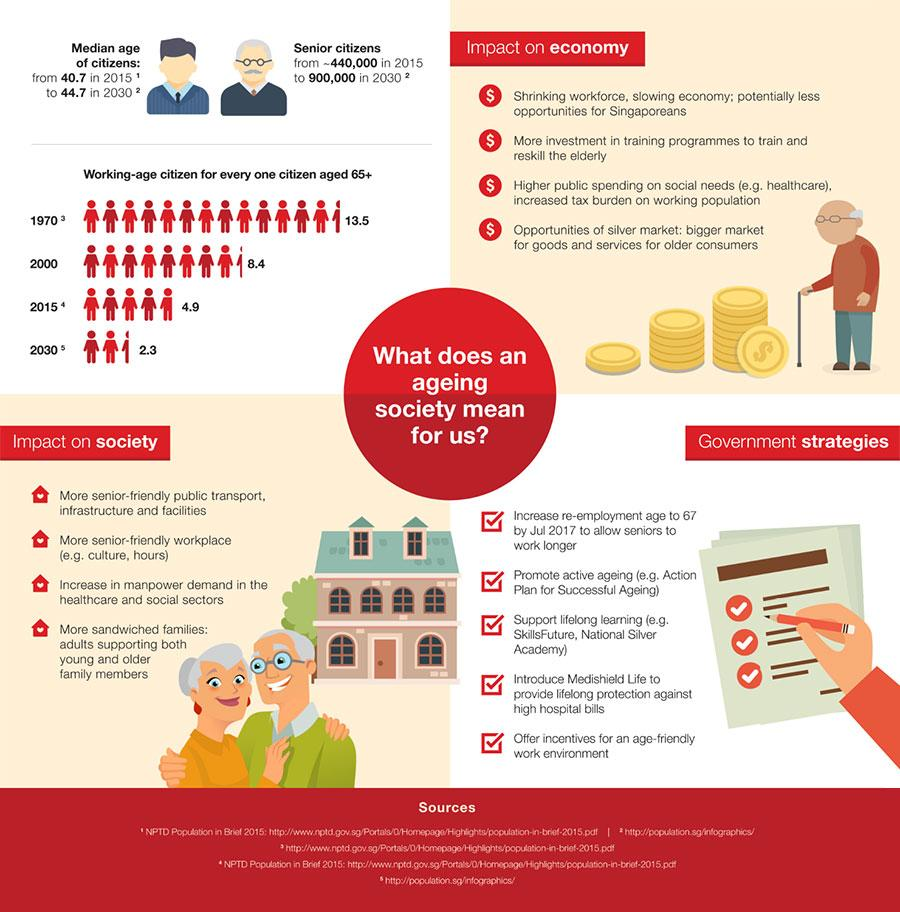Identify some key points in this picture. There are five points listed under the heading "Government Strategies." Under the heading 'Impact on society,' there are 4 points. Four points under the heading "Impact on economy" have been identified. 